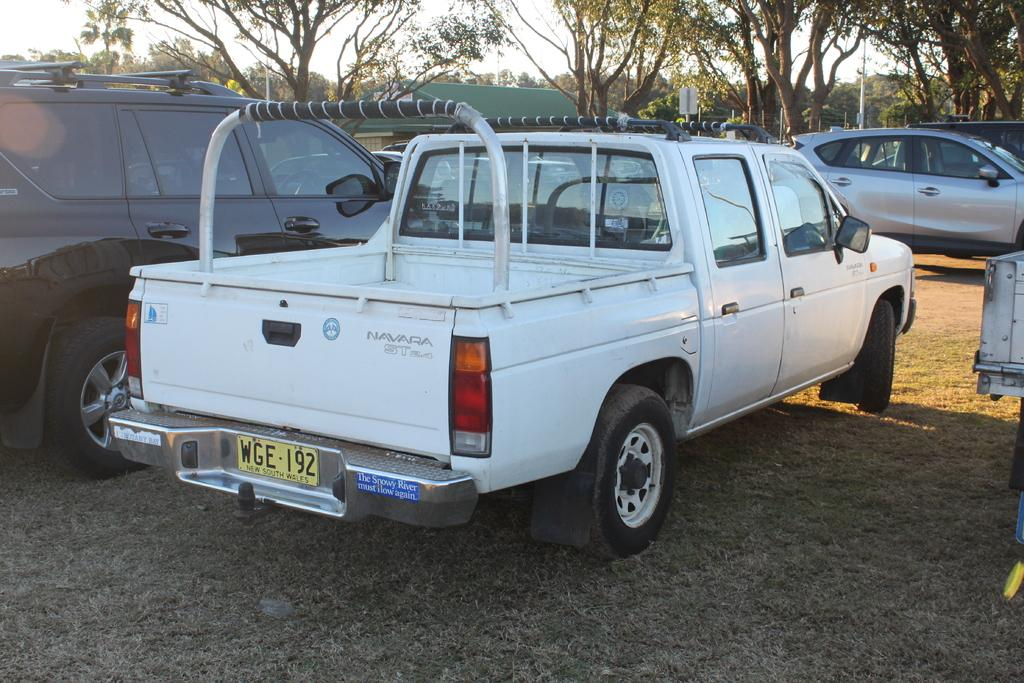What can be seen in the image? There are vehicles in the image. Where are the vehicles located? The vehicles are parked on the ground. What can be seen in the distance in the image? There are trees in the background of the image. Are there any volcanoes visible in the image? No, there are no volcanoes present in the image. How many ducks can be seen swimming in the water near the vehicles? There are no ducks present in the image. 